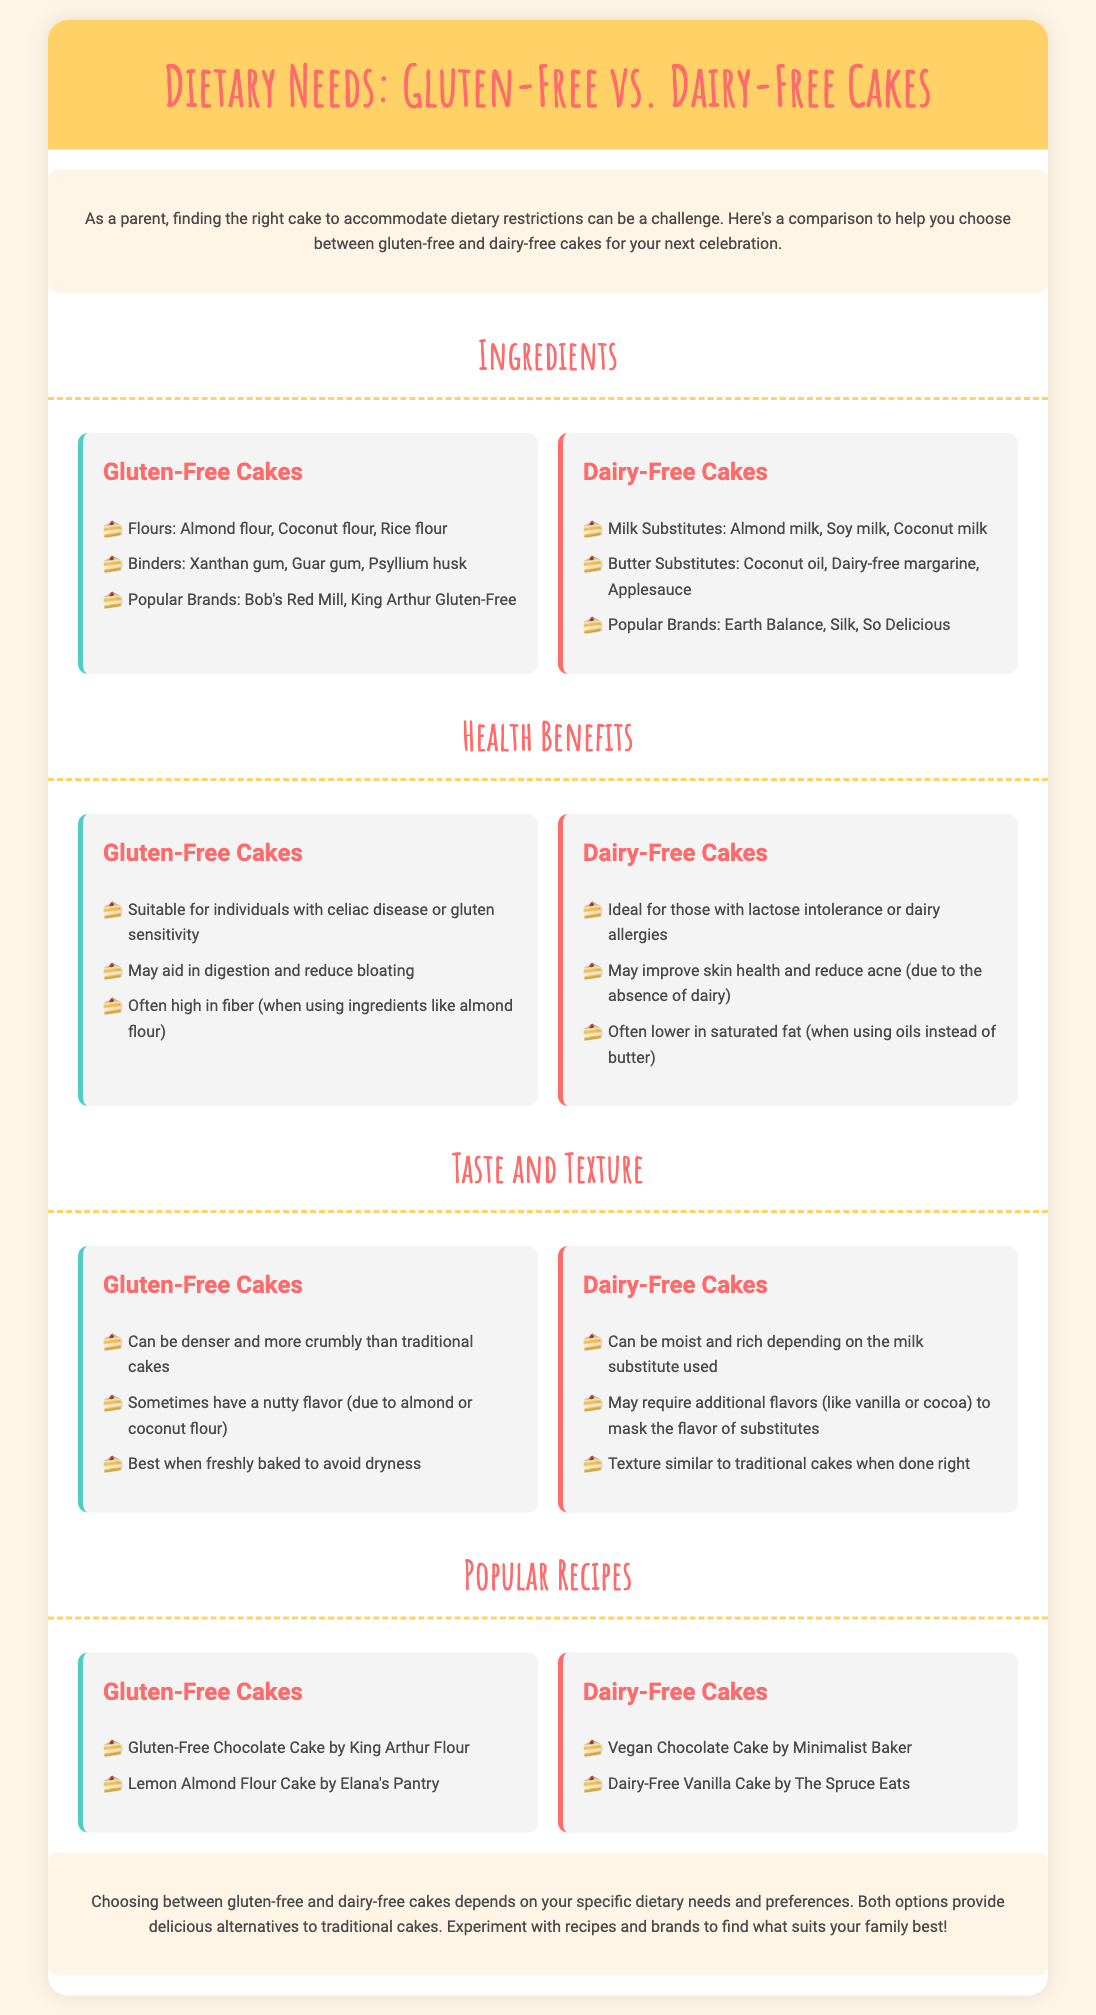what are the popular brands for gluten-free cakes? The popular brands mentioned for gluten-free cakes are Bob's Red Mill and King Arthur Gluten-Free.
Answer: Bob's Red Mill, King Arthur Gluten-Free what are the milk substitutes for dairy-free cakes? The document lists almond milk, soy milk, and coconut milk as milk substitutes for dairy-free cakes.
Answer: Almond milk, Soy milk, Coconut milk which cake is suitable for individuals with celiac disease? The document states that gluten-free cakes are suitable for individuals with celiac disease.
Answer: Gluten-Free Cakes which cake type is noted for potentially being lower in saturated fat? The document mentions that dairy-free cakes can be lower in saturated fat.
Answer: Dairy-Free Cakes what flavor is noted for gluten-free cakes due to their flour? The document states that gluten-free cakes sometimes have a nutty flavor due to almond or coconut flour.
Answer: Nutty flavor which recipe is mentioned as a gluten-free option? The gluten-free recipe mentioned is Gluten-Free Chocolate Cake by King Arthur Flour.
Answer: Gluten-Free Chocolate Cake by King Arthur Flour what is a common characteristic of dairy-free cakes in terms of texture? The document mentions that dairy-free cakes can be moist and rich depending on the milk substitute used.
Answer: Moist and rich how do the taste and texture of gluten-free cakes often compare to traditional cakes? The document states that gluten-free cakes can be denser and more crumbly than traditional cakes.
Answer: Denser and more crumbly which cake type is recommended for lactose intolerance? The document indicates that dairy-free cakes are ideal for those with lactose intolerance.
Answer: Dairy-Free Cakes 